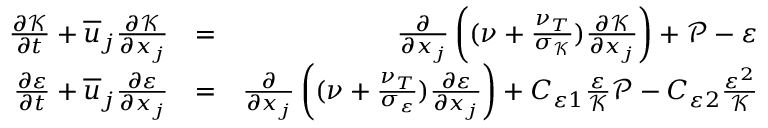Convert formula to latex. <formula><loc_0><loc_0><loc_500><loc_500>\begin{array} { r l r } { \frac { \partial \mathcal { K } } { \partial t } + \overline { u } _ { j } \frac { \partial \mathcal { K } } { \partial x _ { j } } } & { = } & { \frac { \partial } { \partial x _ { j } } \left ( ( \nu + \frac { \nu _ { T } } { \sigma _ { \mathcal { K } } } ) \frac { \partial \mathcal { K } } { \partial x _ { j } } \right ) + \mathcal { P } - \varepsilon } \\ { \frac { \partial \varepsilon } { \partial t } + \overline { u } _ { j } \frac { \partial \varepsilon } { \partial x _ { j } } } & { = } & { \frac { \partial } { \partial x _ { j } } \left ( ( \nu + \frac { \nu _ { T } } { \sigma _ { \mathcal { \varepsilon } } } ) \frac { \partial \varepsilon } { \partial x _ { j } } \right ) + C _ { \varepsilon 1 } \frac { \varepsilon } { \mathcal { K } } \mathcal { P } - C _ { \varepsilon 2 } \frac { \varepsilon ^ { 2 } } { \mathcal { K } } } \end{array}</formula> 